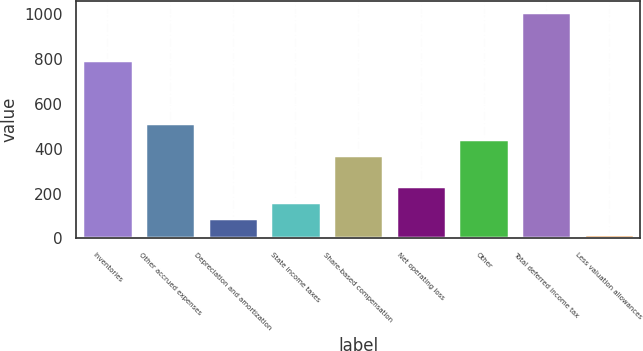Convert chart. <chart><loc_0><loc_0><loc_500><loc_500><bar_chart><fcel>Inventories<fcel>Other accrued expenses<fcel>Depreciation and amortization<fcel>State income taxes<fcel>Share-based compensation<fcel>Net operating loss<fcel>Other<fcel>Total deferred income tax<fcel>Less valuation allowances<nl><fcel>797.42<fcel>514.94<fcel>91.22<fcel>161.84<fcel>373.7<fcel>232.46<fcel>444.32<fcel>1009.28<fcel>20.6<nl></chart> 